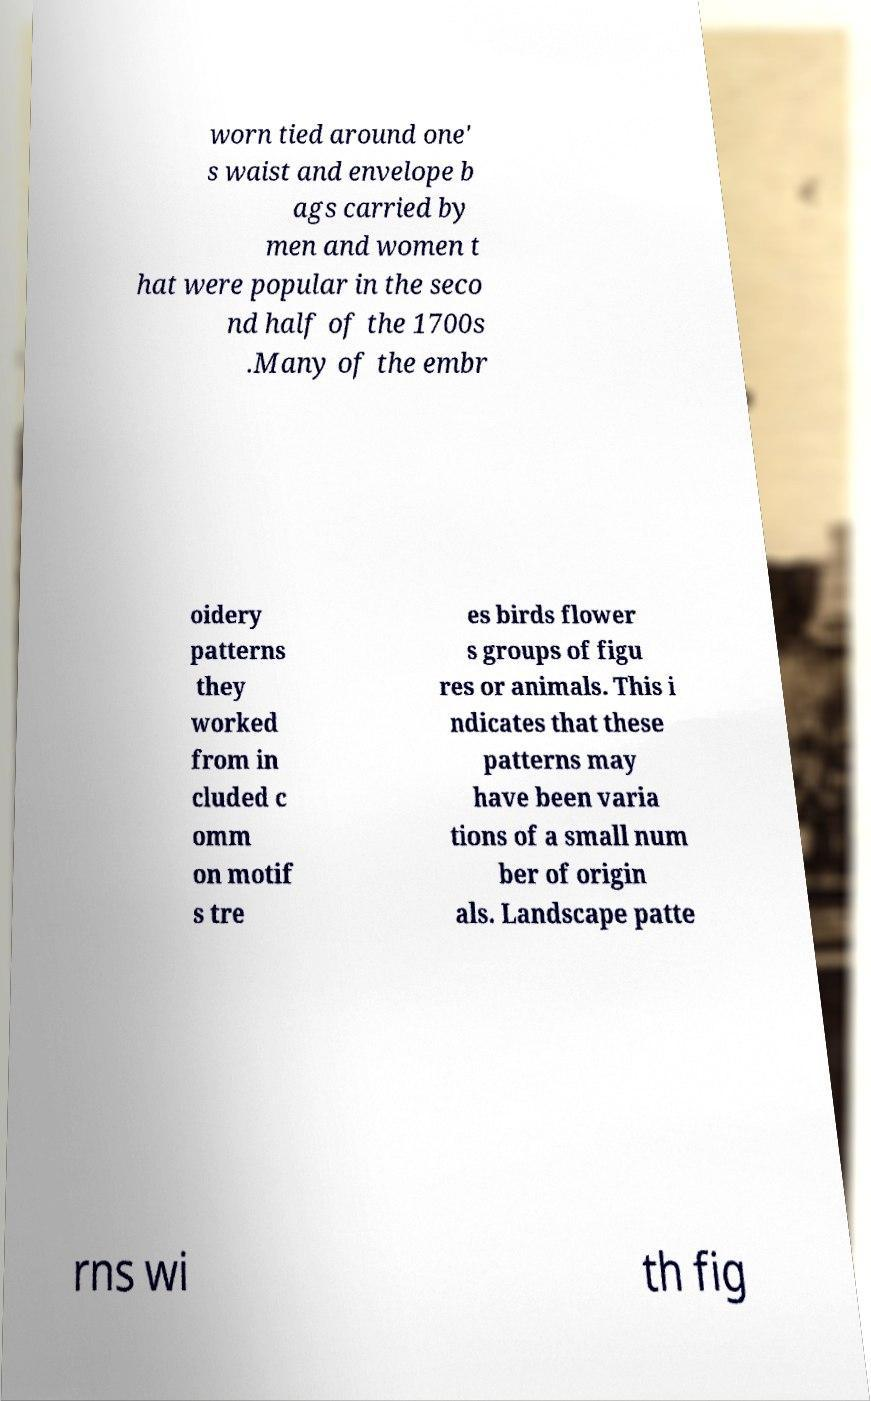Could you extract and type out the text from this image? worn tied around one' s waist and envelope b ags carried by men and women t hat were popular in the seco nd half of the 1700s .Many of the embr oidery patterns they worked from in cluded c omm on motif s tre es birds flower s groups of figu res or animals. This i ndicates that these patterns may have been varia tions of a small num ber of origin als. Landscape patte rns wi th fig 